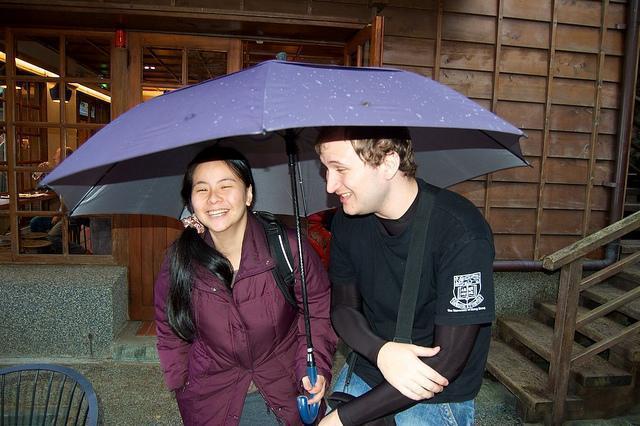How many umbrellas are there?
Give a very brief answer. 1. How many people are in the picture?
Give a very brief answer. 2. 